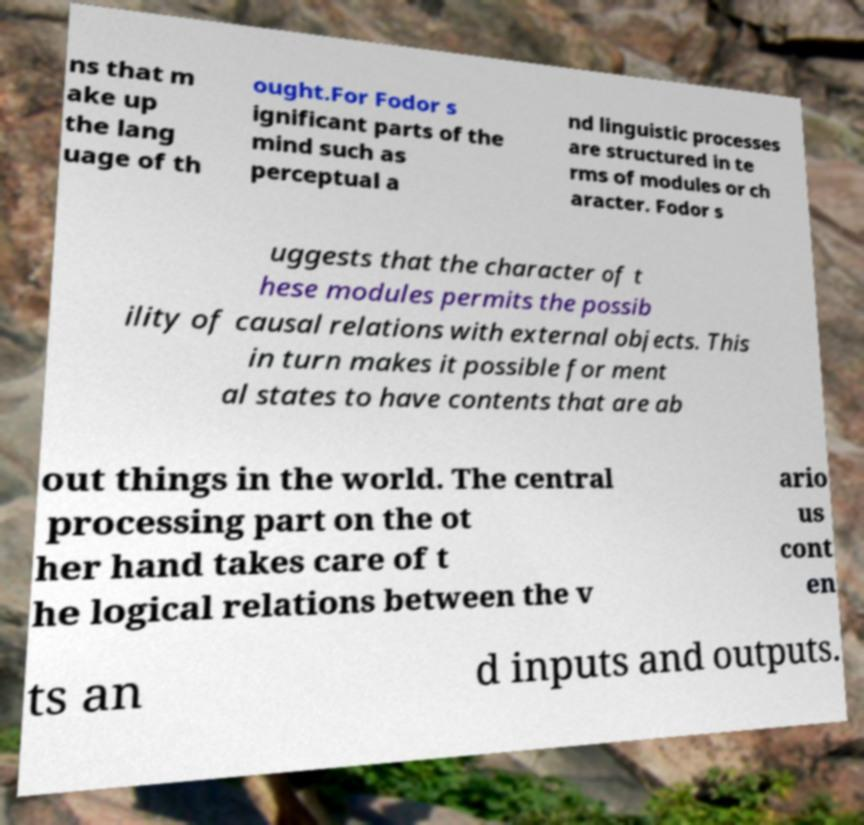There's text embedded in this image that I need extracted. Can you transcribe it verbatim? ns that m ake up the lang uage of th ought.For Fodor s ignificant parts of the mind such as perceptual a nd linguistic processes are structured in te rms of modules or ch aracter. Fodor s uggests that the character of t hese modules permits the possib ility of causal relations with external objects. This in turn makes it possible for ment al states to have contents that are ab out things in the world. The central processing part on the ot her hand takes care of t he logical relations between the v ario us cont en ts an d inputs and outputs. 